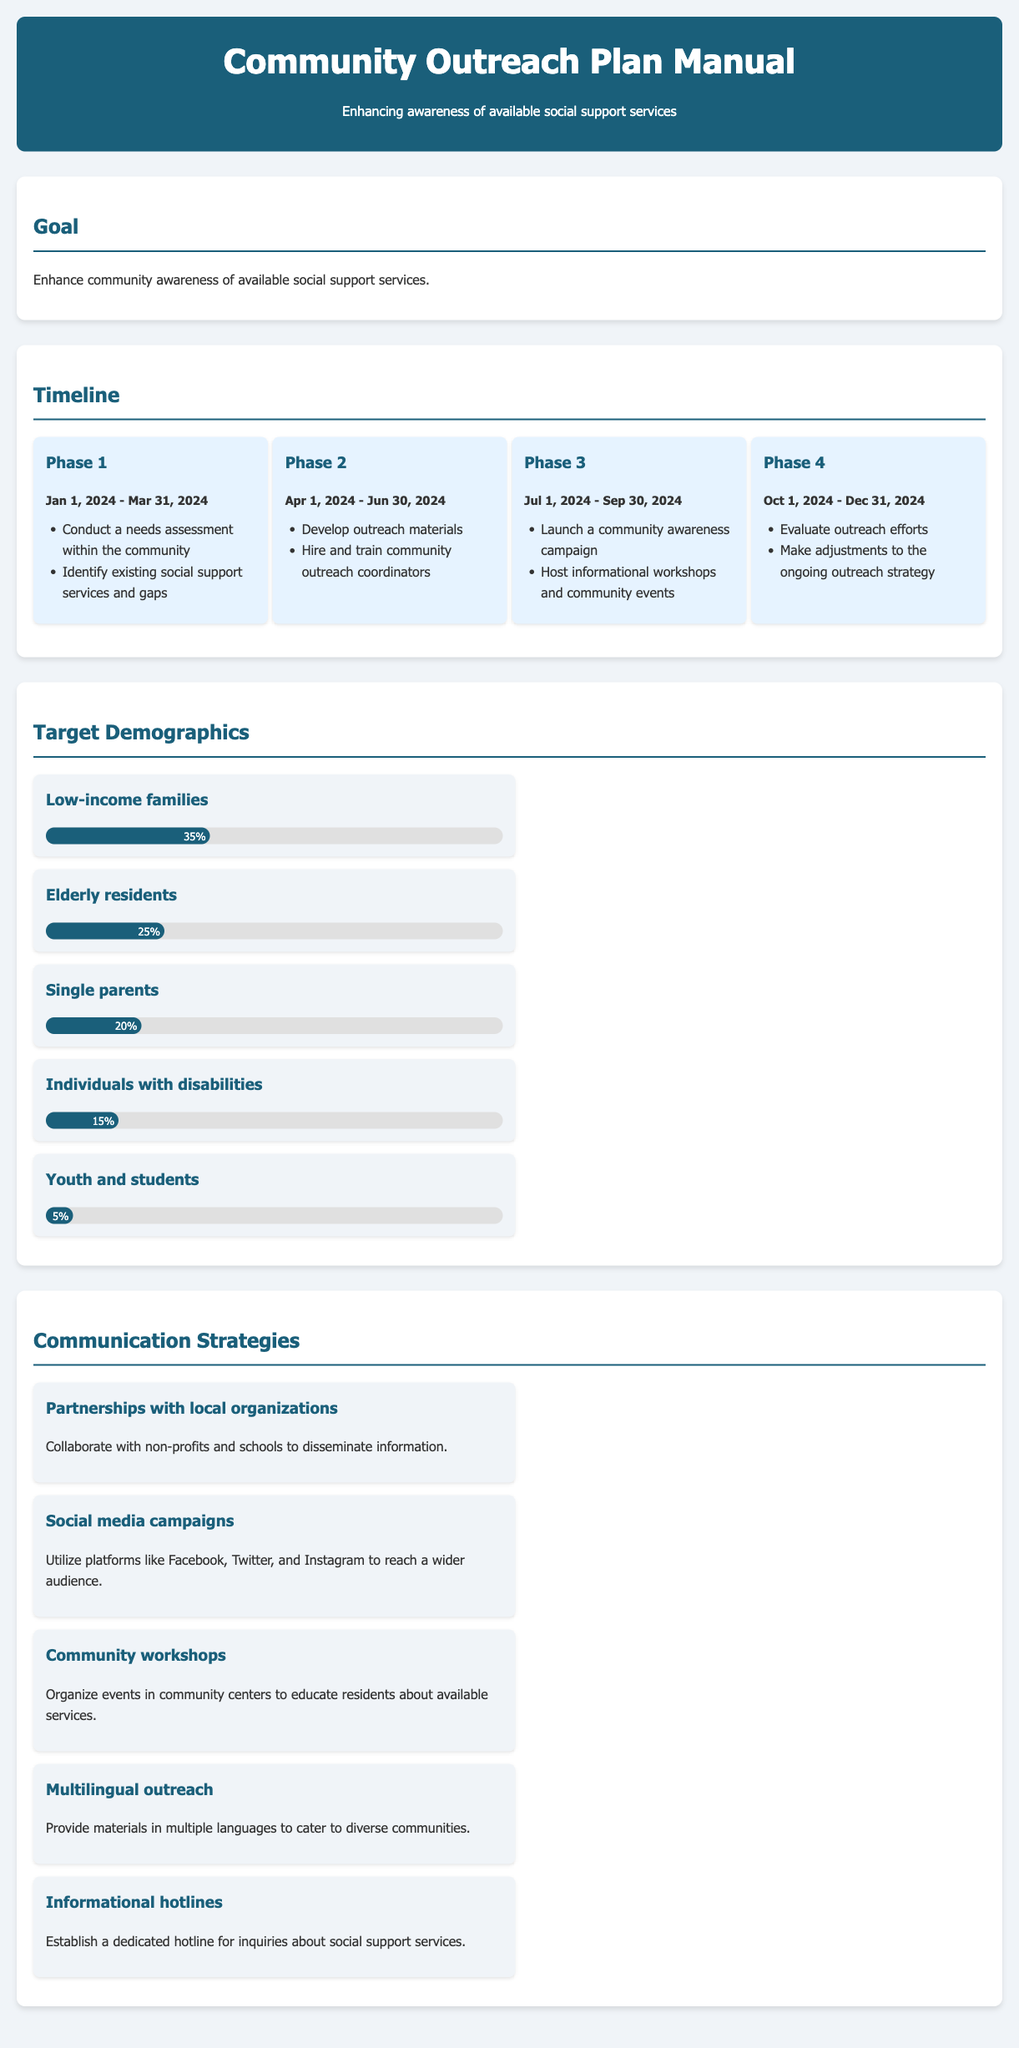What is the primary goal of the outreach plan? The primary goal is to enhance community awareness of available social support services.
Answer: Enhance community awareness of available social support services When does Phase 1 of the outreach plan begin? Phase 1 starts on January 1, 2024, as indicated in the timeline section.
Answer: January 1, 2024 Which demographic has the highest target percentage? The document lists low-income families as the demographic with the highest target percentage at 35%.
Answer: Low-income families What communication strategy involves working with non-profits? The strategy that includes collaboration with non-profits is partnerships with local organizations.
Answer: Partnerships with local organizations How long is Phase 3 scheduled to last? Phase 3 is scheduled to run from July 1, 2024, to September 30, 2024, totaling three months.
Answer: Three months What is the percentage of youth and students targeted in the plan? The document states that youth and students account for 5% of the targeted demographics.
Answer: 5% What type of outreach is planned to cater to different languages? The manual specifies multilingual outreach to provide materials in multiple languages.
Answer: Multilingual outreach Which phase focuses on evaluating outreach efforts? Phase 4 is dedicated to evaluating the outreach efforts and making adjustments.
Answer: Phase 4 